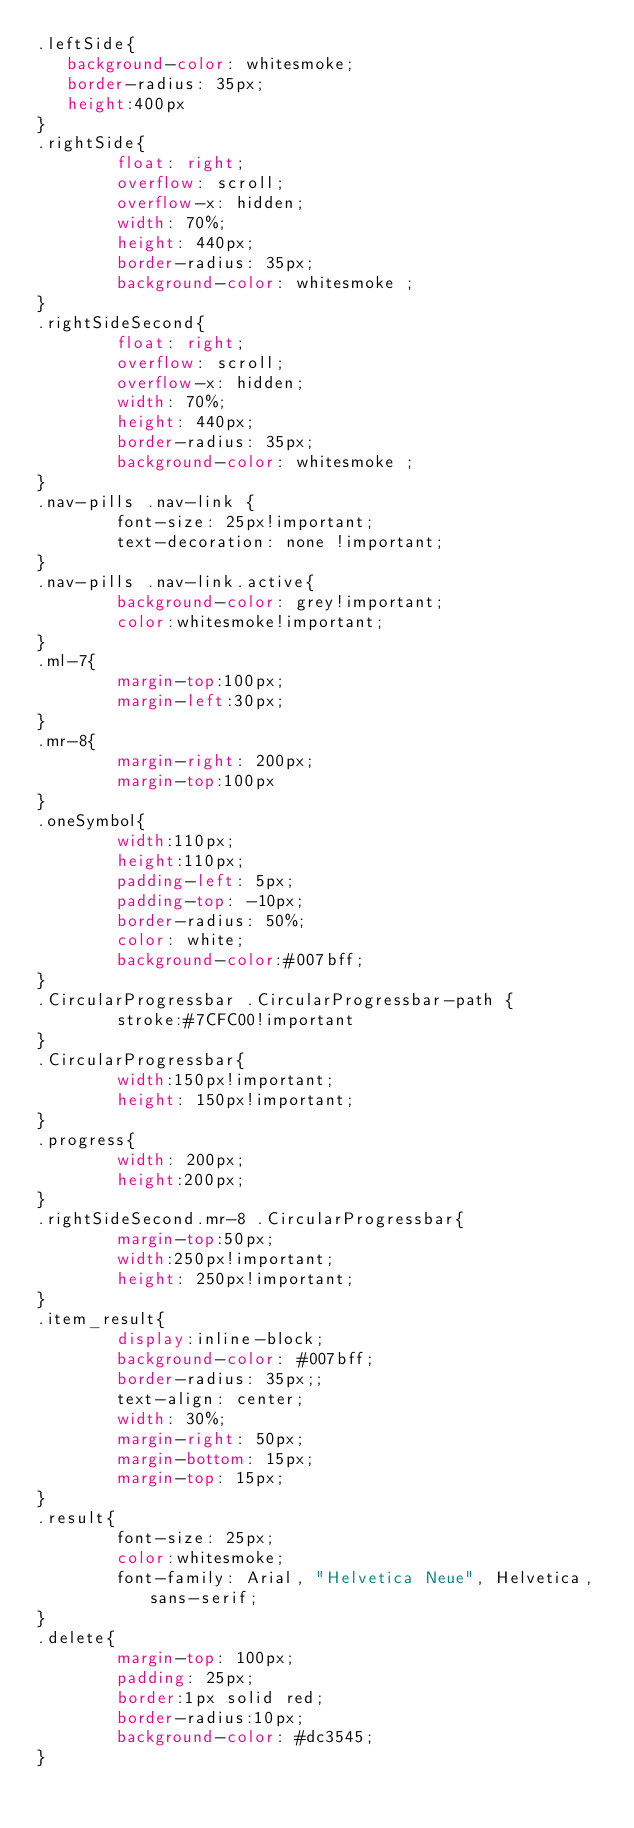<code> <loc_0><loc_0><loc_500><loc_500><_CSS_>.leftSide{
   background-color: whitesmoke;
   border-radius: 35px;
   height:400px
}
.rightSide{
        float: right;
        overflow: scroll;
        overflow-x: hidden;
        width: 70%;
        height: 440px;
        border-radius: 35px;
        background-color: whitesmoke ;
}
.rightSideSecond{
        float: right;
        overflow: scroll;
        overflow-x: hidden;
        width: 70%;
        height: 440px;
        border-radius: 35px;
        background-color: whitesmoke ;
}
.nav-pills .nav-link {
        font-size: 25px!important;
        text-decoration: none !important;
}
.nav-pills .nav-link.active{
        background-color: grey!important;
        color:whitesmoke!important;
}
.ml-7{
        margin-top:100px;
        margin-left:30px;
}
.mr-8{
        margin-right: 200px;
        margin-top:100px
}
.oneSymbol{
        width:110px;
        height:110px;
        padding-left: 5px;
        padding-top: -10px;        
        border-radius: 50%;
        color: white;
        background-color:#007bff;
}
.CircularProgressbar .CircularProgressbar-path {
        stroke:#7CFC00!important
}
.CircularProgressbar{
        width:150px!important;
        height: 150px!important;
}
.progress{
        width: 200px;
        height:200px;
}
.rightSideSecond.mr-8 .CircularProgressbar{
        margin-top:50px;
        width:250px!important;
        height: 250px!important; 
}
.item_result{
        display:inline-block;
        background-color: #007bff;
        border-radius: 35px;;
        text-align: center;
        width: 30%;
        margin-right: 50px;
        margin-bottom: 15px;
        margin-top: 15px;
}
.result{
        font-size: 25px;
        color:whitesmoke;
        font-family: Arial, "Helvetica Neue", Helvetica, sans-serif;
}
.delete{
        margin-top: 100px;
        padding: 25px;
        border:1px solid red;
        border-radius:10px;
        background-color: #dc3545;
}</code> 